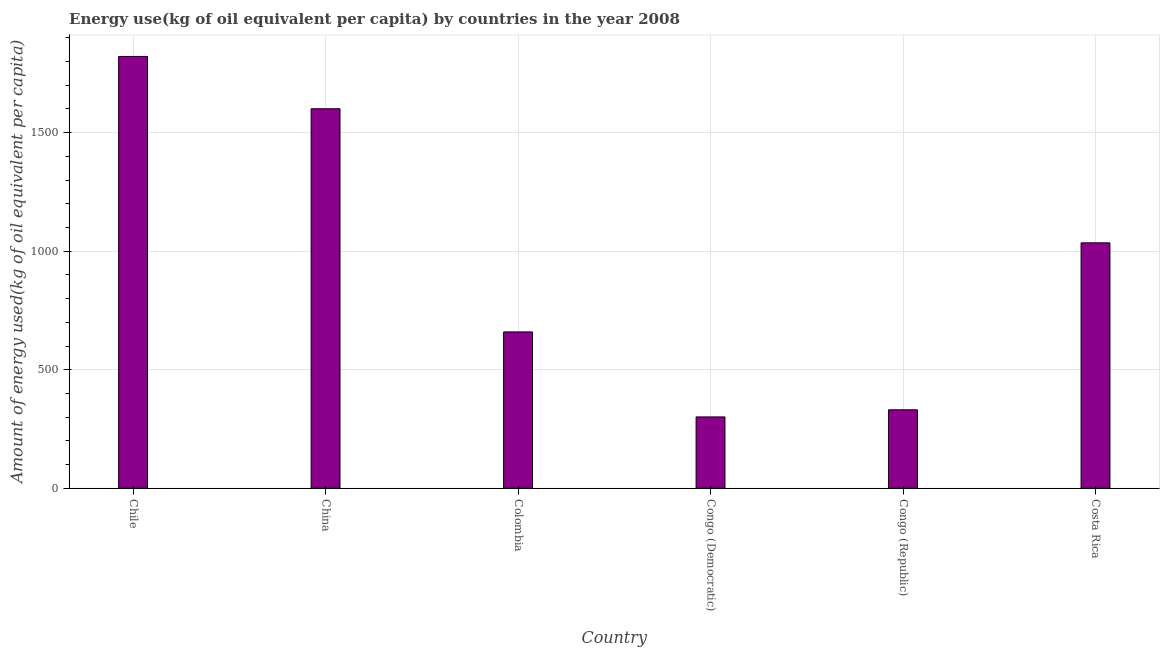What is the title of the graph?
Your answer should be compact. Energy use(kg of oil equivalent per capita) by countries in the year 2008. What is the label or title of the Y-axis?
Give a very brief answer. Amount of energy used(kg of oil equivalent per capita). What is the amount of energy used in China?
Ensure brevity in your answer.  1601.03. Across all countries, what is the maximum amount of energy used?
Give a very brief answer. 1821.59. Across all countries, what is the minimum amount of energy used?
Make the answer very short. 300.97. In which country was the amount of energy used maximum?
Give a very brief answer. Chile. In which country was the amount of energy used minimum?
Your answer should be very brief. Congo (Democratic). What is the sum of the amount of energy used?
Your response must be concise. 5749.58. What is the difference between the amount of energy used in Chile and Congo (Republic)?
Keep it short and to the point. 1490.54. What is the average amount of energy used per country?
Offer a terse response. 958.26. What is the median amount of energy used?
Provide a short and direct response. 847.46. What is the ratio of the amount of energy used in China to that in Congo (Republic)?
Your response must be concise. 4.84. Is the difference between the amount of energy used in Colombia and Costa Rica greater than the difference between any two countries?
Your answer should be compact. No. What is the difference between the highest and the second highest amount of energy used?
Your answer should be compact. 220.56. What is the difference between the highest and the lowest amount of energy used?
Provide a succinct answer. 1520.62. In how many countries, is the amount of energy used greater than the average amount of energy used taken over all countries?
Make the answer very short. 3. How many bars are there?
Ensure brevity in your answer.  6. Are all the bars in the graph horizontal?
Provide a succinct answer. No. What is the difference between two consecutive major ticks on the Y-axis?
Your answer should be compact. 500. Are the values on the major ticks of Y-axis written in scientific E-notation?
Give a very brief answer. No. What is the Amount of energy used(kg of oil equivalent per capita) of Chile?
Your answer should be compact. 1821.59. What is the Amount of energy used(kg of oil equivalent per capita) in China?
Your response must be concise. 1601.03. What is the Amount of energy used(kg of oil equivalent per capita) in Colombia?
Offer a terse response. 659.61. What is the Amount of energy used(kg of oil equivalent per capita) of Congo (Democratic)?
Provide a short and direct response. 300.97. What is the Amount of energy used(kg of oil equivalent per capita) of Congo (Republic)?
Make the answer very short. 331.06. What is the Amount of energy used(kg of oil equivalent per capita) in Costa Rica?
Keep it short and to the point. 1035.32. What is the difference between the Amount of energy used(kg of oil equivalent per capita) in Chile and China?
Ensure brevity in your answer.  220.56. What is the difference between the Amount of energy used(kg of oil equivalent per capita) in Chile and Colombia?
Keep it short and to the point. 1161.98. What is the difference between the Amount of energy used(kg of oil equivalent per capita) in Chile and Congo (Democratic)?
Provide a short and direct response. 1520.62. What is the difference between the Amount of energy used(kg of oil equivalent per capita) in Chile and Congo (Republic)?
Keep it short and to the point. 1490.54. What is the difference between the Amount of energy used(kg of oil equivalent per capita) in Chile and Costa Rica?
Your response must be concise. 786.28. What is the difference between the Amount of energy used(kg of oil equivalent per capita) in China and Colombia?
Your answer should be very brief. 941.42. What is the difference between the Amount of energy used(kg of oil equivalent per capita) in China and Congo (Democratic)?
Offer a terse response. 1300.06. What is the difference between the Amount of energy used(kg of oil equivalent per capita) in China and Congo (Republic)?
Offer a very short reply. 1269.97. What is the difference between the Amount of energy used(kg of oil equivalent per capita) in China and Costa Rica?
Give a very brief answer. 565.71. What is the difference between the Amount of energy used(kg of oil equivalent per capita) in Colombia and Congo (Democratic)?
Provide a short and direct response. 358.64. What is the difference between the Amount of energy used(kg of oil equivalent per capita) in Colombia and Congo (Republic)?
Ensure brevity in your answer.  328.55. What is the difference between the Amount of energy used(kg of oil equivalent per capita) in Colombia and Costa Rica?
Give a very brief answer. -375.71. What is the difference between the Amount of energy used(kg of oil equivalent per capita) in Congo (Democratic) and Congo (Republic)?
Keep it short and to the point. -30.09. What is the difference between the Amount of energy used(kg of oil equivalent per capita) in Congo (Democratic) and Costa Rica?
Make the answer very short. -734.35. What is the difference between the Amount of energy used(kg of oil equivalent per capita) in Congo (Republic) and Costa Rica?
Offer a terse response. -704.26. What is the ratio of the Amount of energy used(kg of oil equivalent per capita) in Chile to that in China?
Provide a short and direct response. 1.14. What is the ratio of the Amount of energy used(kg of oil equivalent per capita) in Chile to that in Colombia?
Provide a short and direct response. 2.76. What is the ratio of the Amount of energy used(kg of oil equivalent per capita) in Chile to that in Congo (Democratic)?
Your answer should be very brief. 6.05. What is the ratio of the Amount of energy used(kg of oil equivalent per capita) in Chile to that in Congo (Republic)?
Keep it short and to the point. 5.5. What is the ratio of the Amount of energy used(kg of oil equivalent per capita) in Chile to that in Costa Rica?
Provide a short and direct response. 1.76. What is the ratio of the Amount of energy used(kg of oil equivalent per capita) in China to that in Colombia?
Offer a very short reply. 2.43. What is the ratio of the Amount of energy used(kg of oil equivalent per capita) in China to that in Congo (Democratic)?
Your answer should be very brief. 5.32. What is the ratio of the Amount of energy used(kg of oil equivalent per capita) in China to that in Congo (Republic)?
Your answer should be compact. 4.84. What is the ratio of the Amount of energy used(kg of oil equivalent per capita) in China to that in Costa Rica?
Keep it short and to the point. 1.55. What is the ratio of the Amount of energy used(kg of oil equivalent per capita) in Colombia to that in Congo (Democratic)?
Ensure brevity in your answer.  2.19. What is the ratio of the Amount of energy used(kg of oil equivalent per capita) in Colombia to that in Congo (Republic)?
Ensure brevity in your answer.  1.99. What is the ratio of the Amount of energy used(kg of oil equivalent per capita) in Colombia to that in Costa Rica?
Ensure brevity in your answer.  0.64. What is the ratio of the Amount of energy used(kg of oil equivalent per capita) in Congo (Democratic) to that in Congo (Republic)?
Keep it short and to the point. 0.91. What is the ratio of the Amount of energy used(kg of oil equivalent per capita) in Congo (Democratic) to that in Costa Rica?
Your answer should be compact. 0.29. What is the ratio of the Amount of energy used(kg of oil equivalent per capita) in Congo (Republic) to that in Costa Rica?
Your response must be concise. 0.32. 